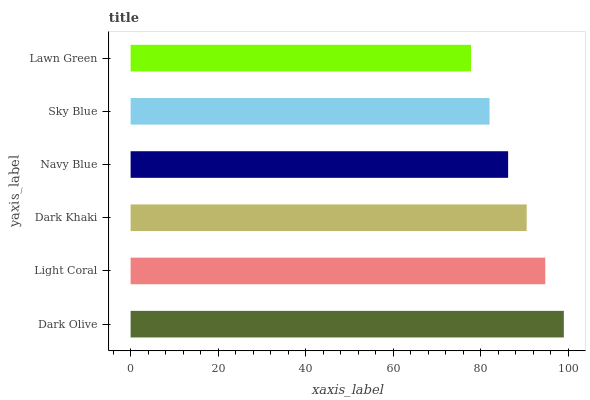Is Lawn Green the minimum?
Answer yes or no. Yes. Is Dark Olive the maximum?
Answer yes or no. Yes. Is Light Coral the minimum?
Answer yes or no. No. Is Light Coral the maximum?
Answer yes or no. No. Is Dark Olive greater than Light Coral?
Answer yes or no. Yes. Is Light Coral less than Dark Olive?
Answer yes or no. Yes. Is Light Coral greater than Dark Olive?
Answer yes or no. No. Is Dark Olive less than Light Coral?
Answer yes or no. No. Is Dark Khaki the high median?
Answer yes or no. Yes. Is Navy Blue the low median?
Answer yes or no. Yes. Is Light Coral the high median?
Answer yes or no. No. Is Light Coral the low median?
Answer yes or no. No. 